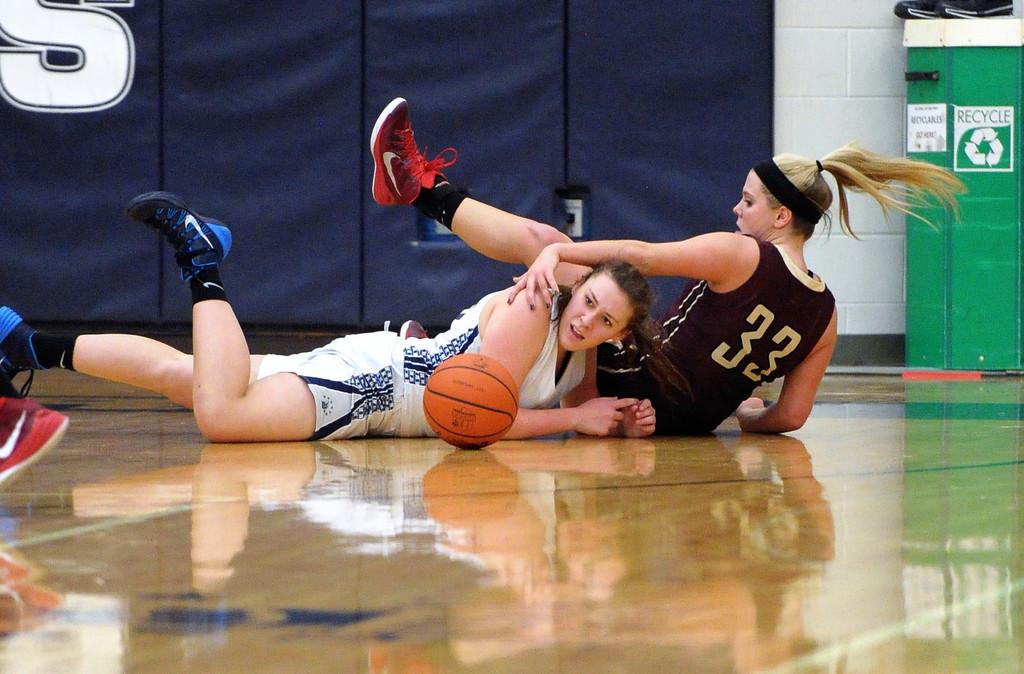What is the number of the girl with a red shirt?
Your answer should be compact. 33. 